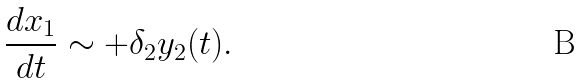Convert formula to latex. <formula><loc_0><loc_0><loc_500><loc_500>\frac { d x _ { 1 } } { d t } \sim + \delta _ { 2 } y _ { 2 } ( t ) .</formula> 